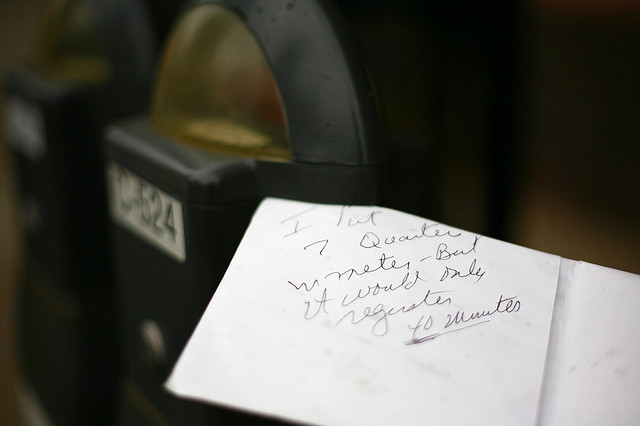Identify the text contained in this image. C-524 I Quarter W only would A minutes regular 